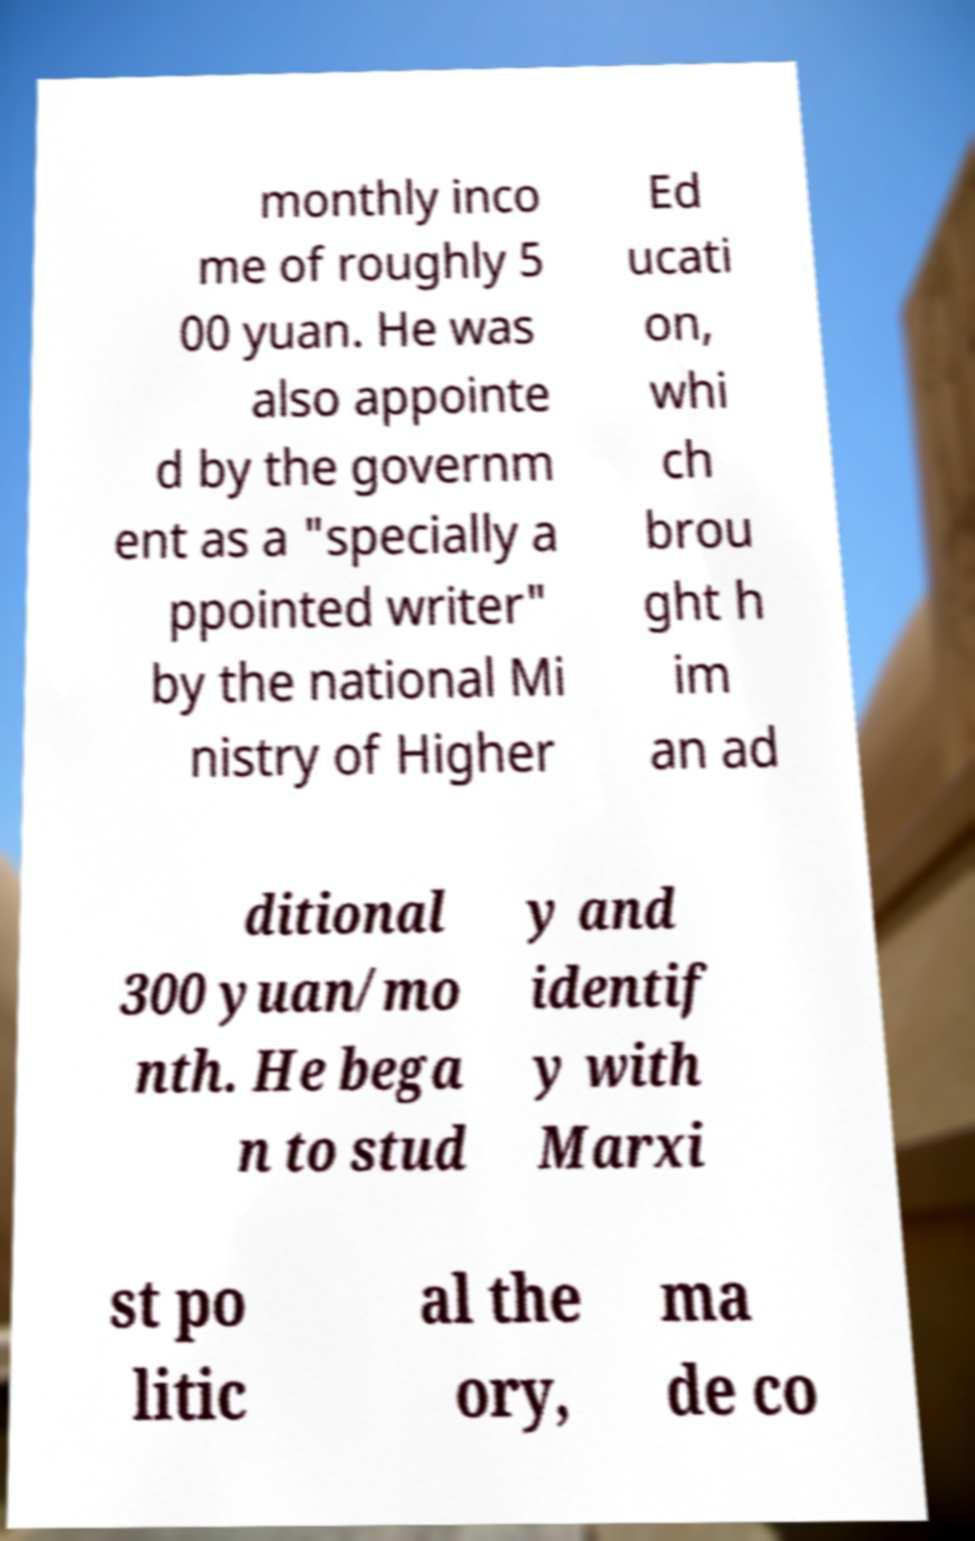Could you assist in decoding the text presented in this image and type it out clearly? monthly inco me of roughly 5 00 yuan. He was also appointe d by the governm ent as a "specially a ppointed writer" by the national Mi nistry of Higher Ed ucati on, whi ch brou ght h im an ad ditional 300 yuan/mo nth. He bega n to stud y and identif y with Marxi st po litic al the ory, ma de co 